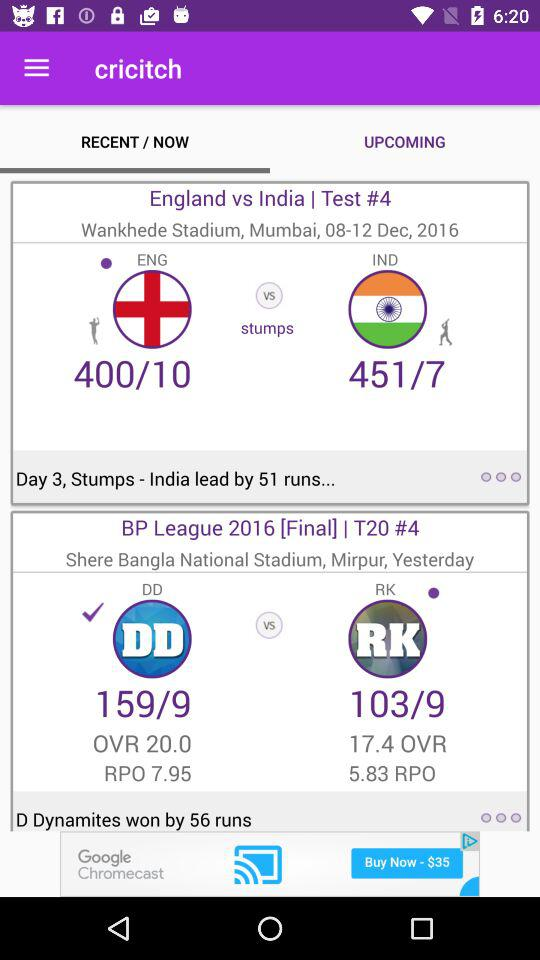How many more runs did the team with 159/9 score than the team with 103/9?
Answer the question using a single word or phrase. 56 